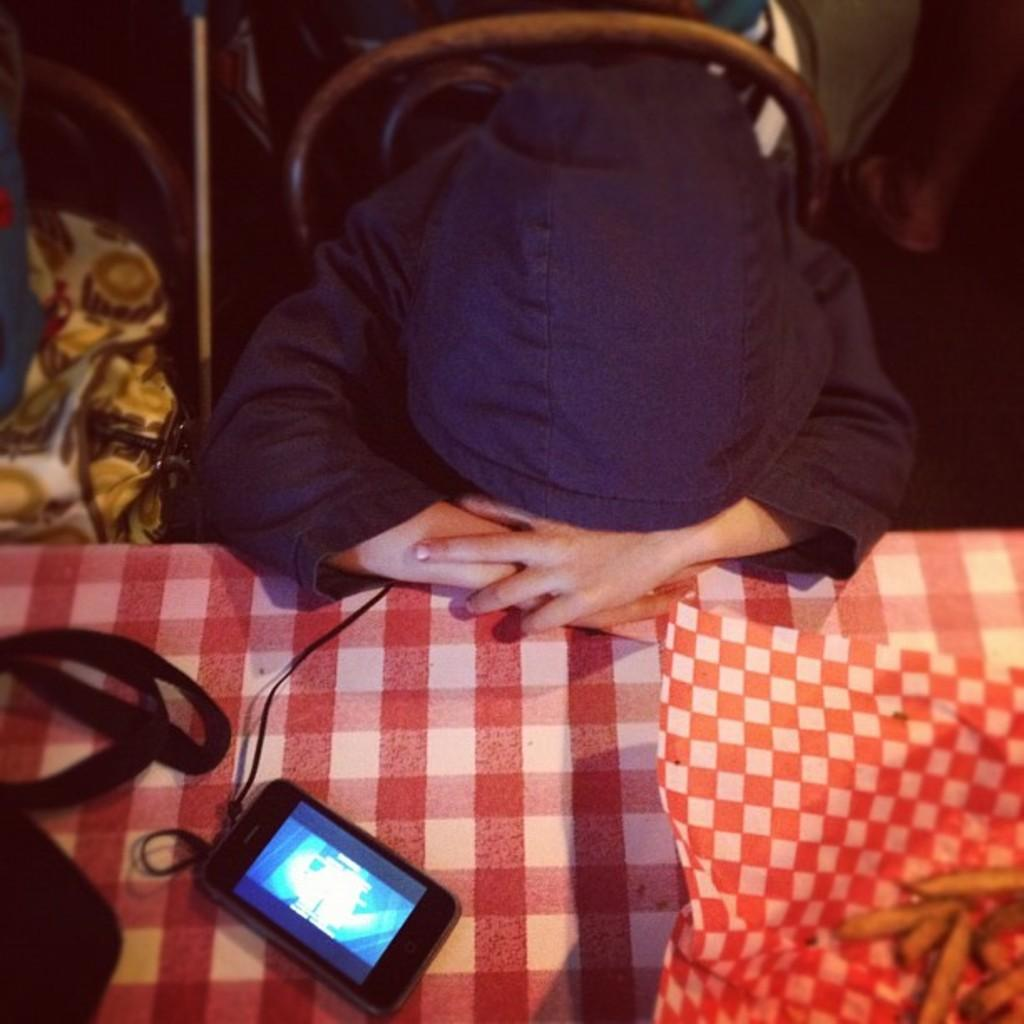Who or what is present in the image? There is a person in the image. What is the person wearing? The person is wearing a black jacket. What is in front of the person? There is a table in front of the person. What can be seen on the table? There is a mobile phone, a wire, and other objects on the table. What type of lace is being used in the army process depicted in the image? There is no army or lace present in the image; it features a person wearing a black jacket with a table in front of them. 